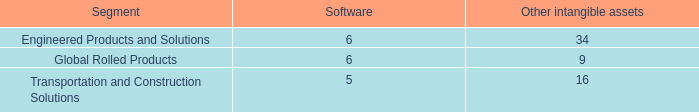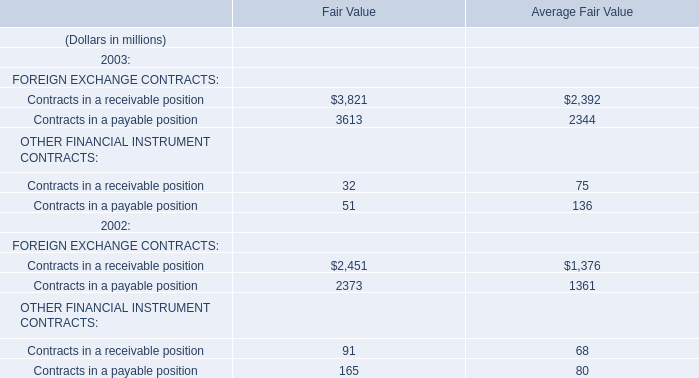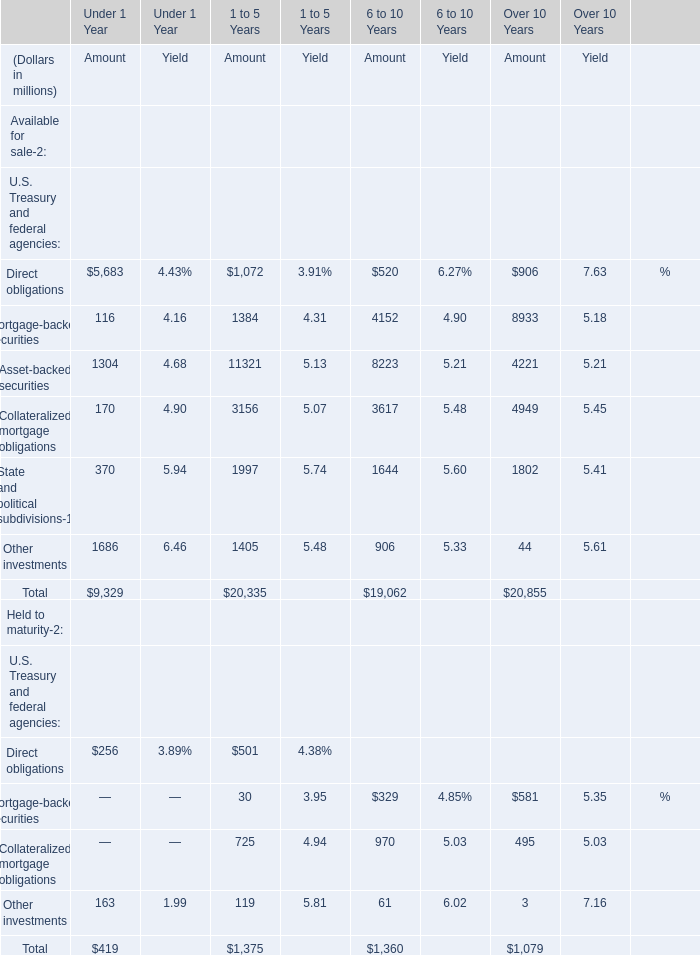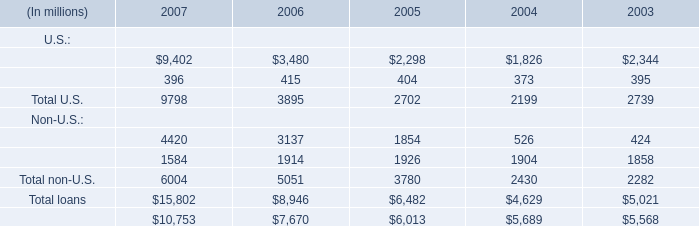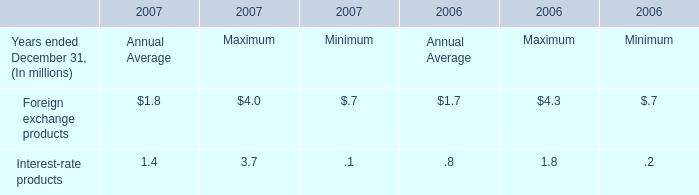What's the growth rate of Commercial and financial for U.S. in 2007? 
Computations: ((9402 - 3480) / 3480)
Answer: 1.70172. 